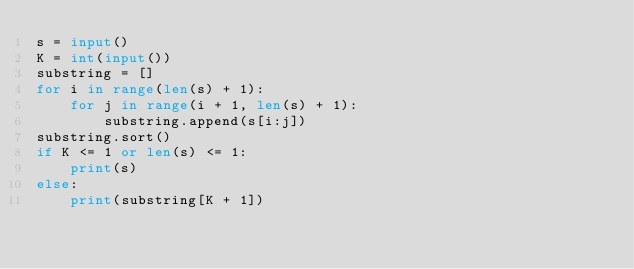<code> <loc_0><loc_0><loc_500><loc_500><_Python_>s = input()
K = int(input())
substring = []
for i in range(len(s) + 1):
	for j in range(i + 1, len(s) + 1):
		substring.append(s[i:j])
substring.sort()
if K <= 1 or len(s) <= 1:
	print(s)
else:
	print(substring[K + 1])</code> 